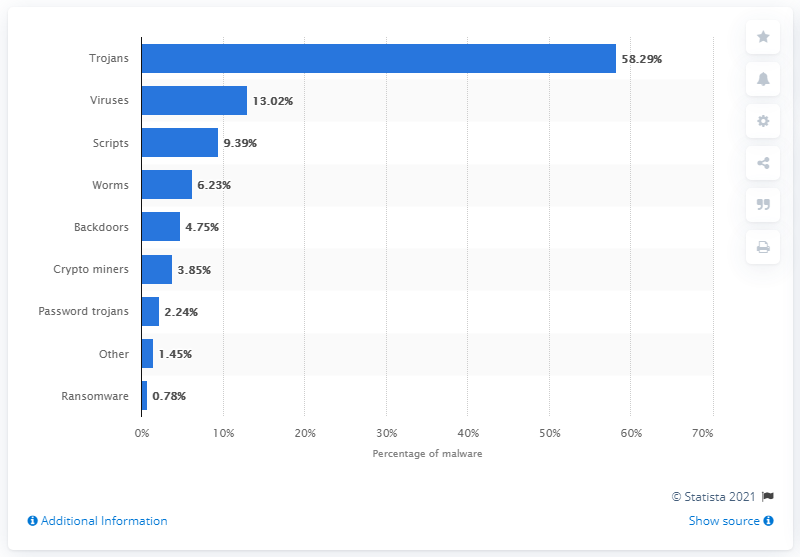List a handful of essential elements in this visual. In 2019, trojans accounted for approximately 58.29% of all malware incidents. 